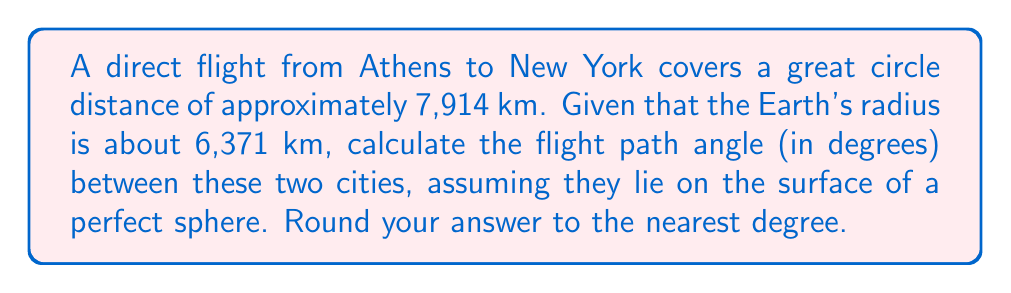Show me your answer to this math problem. To solve this problem, we'll use the formula for the central angle in a sphere, which is equivalent to the flight path angle:

1) The formula for the central angle $\theta$ (in radians) is:

   $$\theta = \frac{s}{R}$$

   Where $s$ is the arc length (great circle distance) and $R$ is the radius of the sphere.

2) We're given:
   $s = 7914$ km
   $R = 6371$ km

3) Substituting these values:

   $$\theta = \frac{7914}{6371} \approx 1.2422 \text{ radians}$$

4) To convert radians to degrees, we multiply by $\frac{180}{\pi}$:

   $$\theta_{degrees} = 1.2422 \cdot \frac{180}{\pi} \approx 71.17°$$

5) Rounding to the nearest degree:

   $$\theta_{degrees} \approx 71°$$
Answer: $71°$ 